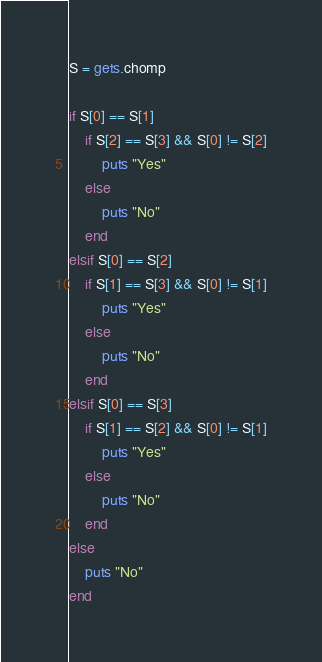<code> <loc_0><loc_0><loc_500><loc_500><_Ruby_>S = gets.chomp

if S[0] == S[1]
    if S[2] == S[3] && S[0] != S[2]
        puts "Yes"
    else
        puts "No"
    end
elsif S[0] == S[2]
    if S[1] == S[3] && S[0] != S[1]
        puts "Yes"
    else
        puts "No"
    end
elsif S[0] == S[3]
    if S[1] == S[2] && S[0] != S[1]
        puts "Yes"
    else
        puts "No"
    end
else
    puts "No"
end</code> 